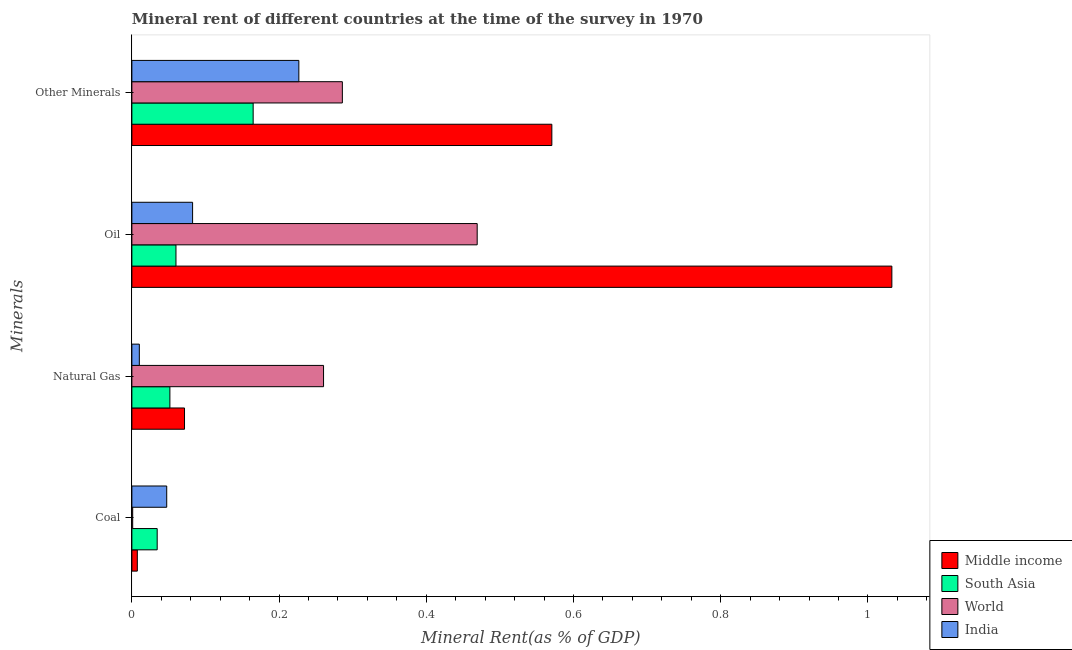How many groups of bars are there?
Provide a succinct answer. 4. Are the number of bars per tick equal to the number of legend labels?
Provide a short and direct response. Yes. Are the number of bars on each tick of the Y-axis equal?
Your answer should be compact. Yes. What is the label of the 3rd group of bars from the top?
Your response must be concise. Natural Gas. What is the  rent of other minerals in South Asia?
Provide a short and direct response. 0.16. Across all countries, what is the maximum natural gas rent?
Your response must be concise. 0.26. Across all countries, what is the minimum coal rent?
Make the answer very short. 0. What is the total coal rent in the graph?
Ensure brevity in your answer.  0.09. What is the difference between the natural gas rent in Middle income and that in South Asia?
Your answer should be very brief. 0.02. What is the difference between the  rent of other minerals in Middle income and the oil rent in World?
Give a very brief answer. 0.1. What is the average oil rent per country?
Offer a terse response. 0.41. What is the difference between the natural gas rent and coal rent in India?
Offer a terse response. -0.04. What is the ratio of the  rent of other minerals in South Asia to that in World?
Offer a very short reply. 0.58. Is the coal rent in Middle income less than that in India?
Keep it short and to the point. Yes. What is the difference between the highest and the second highest natural gas rent?
Your response must be concise. 0.19. What is the difference between the highest and the lowest coal rent?
Make the answer very short. 0.05. In how many countries, is the coal rent greater than the average coal rent taken over all countries?
Give a very brief answer. 2. Is the sum of the oil rent in World and South Asia greater than the maximum coal rent across all countries?
Offer a very short reply. Yes. What does the 4th bar from the bottom in Other Minerals represents?
Offer a terse response. India. Is it the case that in every country, the sum of the coal rent and natural gas rent is greater than the oil rent?
Your answer should be compact. No. Are all the bars in the graph horizontal?
Give a very brief answer. Yes. What is the difference between two consecutive major ticks on the X-axis?
Offer a terse response. 0.2. Does the graph contain any zero values?
Offer a terse response. No. Does the graph contain grids?
Provide a succinct answer. No. Where does the legend appear in the graph?
Provide a short and direct response. Bottom right. How many legend labels are there?
Give a very brief answer. 4. What is the title of the graph?
Make the answer very short. Mineral rent of different countries at the time of the survey in 1970. What is the label or title of the X-axis?
Ensure brevity in your answer.  Mineral Rent(as % of GDP). What is the label or title of the Y-axis?
Give a very brief answer. Minerals. What is the Mineral Rent(as % of GDP) of Middle income in Coal?
Give a very brief answer. 0.01. What is the Mineral Rent(as % of GDP) in South Asia in Coal?
Provide a short and direct response. 0.03. What is the Mineral Rent(as % of GDP) in World in Coal?
Offer a very short reply. 0. What is the Mineral Rent(as % of GDP) of India in Coal?
Your response must be concise. 0.05. What is the Mineral Rent(as % of GDP) in Middle income in Natural Gas?
Provide a short and direct response. 0.07. What is the Mineral Rent(as % of GDP) in South Asia in Natural Gas?
Give a very brief answer. 0.05. What is the Mineral Rent(as % of GDP) in World in Natural Gas?
Offer a terse response. 0.26. What is the Mineral Rent(as % of GDP) in India in Natural Gas?
Your response must be concise. 0.01. What is the Mineral Rent(as % of GDP) of Middle income in Oil?
Offer a terse response. 1.03. What is the Mineral Rent(as % of GDP) in South Asia in Oil?
Ensure brevity in your answer.  0.06. What is the Mineral Rent(as % of GDP) in World in Oil?
Your answer should be very brief. 0.47. What is the Mineral Rent(as % of GDP) in India in Oil?
Ensure brevity in your answer.  0.08. What is the Mineral Rent(as % of GDP) of Middle income in Other Minerals?
Make the answer very short. 0.57. What is the Mineral Rent(as % of GDP) of South Asia in Other Minerals?
Your response must be concise. 0.16. What is the Mineral Rent(as % of GDP) in World in Other Minerals?
Provide a succinct answer. 0.29. What is the Mineral Rent(as % of GDP) of India in Other Minerals?
Provide a short and direct response. 0.23. Across all Minerals, what is the maximum Mineral Rent(as % of GDP) in Middle income?
Provide a succinct answer. 1.03. Across all Minerals, what is the maximum Mineral Rent(as % of GDP) in South Asia?
Your answer should be compact. 0.16. Across all Minerals, what is the maximum Mineral Rent(as % of GDP) of World?
Provide a succinct answer. 0.47. Across all Minerals, what is the maximum Mineral Rent(as % of GDP) in India?
Give a very brief answer. 0.23. Across all Minerals, what is the minimum Mineral Rent(as % of GDP) of Middle income?
Your answer should be very brief. 0.01. Across all Minerals, what is the minimum Mineral Rent(as % of GDP) of South Asia?
Ensure brevity in your answer.  0.03. Across all Minerals, what is the minimum Mineral Rent(as % of GDP) in World?
Provide a succinct answer. 0. Across all Minerals, what is the minimum Mineral Rent(as % of GDP) of India?
Provide a succinct answer. 0.01. What is the total Mineral Rent(as % of GDP) in Middle income in the graph?
Your answer should be compact. 1.68. What is the total Mineral Rent(as % of GDP) of South Asia in the graph?
Keep it short and to the point. 0.31. What is the total Mineral Rent(as % of GDP) in World in the graph?
Offer a terse response. 1.02. What is the total Mineral Rent(as % of GDP) of India in the graph?
Your answer should be compact. 0.37. What is the difference between the Mineral Rent(as % of GDP) of Middle income in Coal and that in Natural Gas?
Make the answer very short. -0.06. What is the difference between the Mineral Rent(as % of GDP) in South Asia in Coal and that in Natural Gas?
Your answer should be compact. -0.02. What is the difference between the Mineral Rent(as % of GDP) of World in Coal and that in Natural Gas?
Provide a succinct answer. -0.26. What is the difference between the Mineral Rent(as % of GDP) of India in Coal and that in Natural Gas?
Your response must be concise. 0.04. What is the difference between the Mineral Rent(as % of GDP) in Middle income in Coal and that in Oil?
Give a very brief answer. -1.02. What is the difference between the Mineral Rent(as % of GDP) of South Asia in Coal and that in Oil?
Offer a very short reply. -0.03. What is the difference between the Mineral Rent(as % of GDP) in World in Coal and that in Oil?
Ensure brevity in your answer.  -0.47. What is the difference between the Mineral Rent(as % of GDP) in India in Coal and that in Oil?
Provide a short and direct response. -0.04. What is the difference between the Mineral Rent(as % of GDP) in Middle income in Coal and that in Other Minerals?
Provide a succinct answer. -0.56. What is the difference between the Mineral Rent(as % of GDP) of South Asia in Coal and that in Other Minerals?
Make the answer very short. -0.13. What is the difference between the Mineral Rent(as % of GDP) of World in Coal and that in Other Minerals?
Provide a succinct answer. -0.28. What is the difference between the Mineral Rent(as % of GDP) of India in Coal and that in Other Minerals?
Ensure brevity in your answer.  -0.18. What is the difference between the Mineral Rent(as % of GDP) in Middle income in Natural Gas and that in Oil?
Ensure brevity in your answer.  -0.96. What is the difference between the Mineral Rent(as % of GDP) in South Asia in Natural Gas and that in Oil?
Provide a succinct answer. -0.01. What is the difference between the Mineral Rent(as % of GDP) of World in Natural Gas and that in Oil?
Provide a short and direct response. -0.21. What is the difference between the Mineral Rent(as % of GDP) of India in Natural Gas and that in Oil?
Your answer should be compact. -0.07. What is the difference between the Mineral Rent(as % of GDP) of Middle income in Natural Gas and that in Other Minerals?
Give a very brief answer. -0.5. What is the difference between the Mineral Rent(as % of GDP) in South Asia in Natural Gas and that in Other Minerals?
Your response must be concise. -0.11. What is the difference between the Mineral Rent(as % of GDP) of World in Natural Gas and that in Other Minerals?
Offer a terse response. -0.03. What is the difference between the Mineral Rent(as % of GDP) of India in Natural Gas and that in Other Minerals?
Give a very brief answer. -0.22. What is the difference between the Mineral Rent(as % of GDP) in Middle income in Oil and that in Other Minerals?
Offer a terse response. 0.46. What is the difference between the Mineral Rent(as % of GDP) of South Asia in Oil and that in Other Minerals?
Offer a very short reply. -0.1. What is the difference between the Mineral Rent(as % of GDP) of World in Oil and that in Other Minerals?
Ensure brevity in your answer.  0.18. What is the difference between the Mineral Rent(as % of GDP) in India in Oil and that in Other Minerals?
Offer a terse response. -0.14. What is the difference between the Mineral Rent(as % of GDP) of Middle income in Coal and the Mineral Rent(as % of GDP) of South Asia in Natural Gas?
Provide a succinct answer. -0.04. What is the difference between the Mineral Rent(as % of GDP) in Middle income in Coal and the Mineral Rent(as % of GDP) in World in Natural Gas?
Your answer should be very brief. -0.25. What is the difference between the Mineral Rent(as % of GDP) of Middle income in Coal and the Mineral Rent(as % of GDP) of India in Natural Gas?
Offer a terse response. -0. What is the difference between the Mineral Rent(as % of GDP) of South Asia in Coal and the Mineral Rent(as % of GDP) of World in Natural Gas?
Offer a very short reply. -0.23. What is the difference between the Mineral Rent(as % of GDP) in South Asia in Coal and the Mineral Rent(as % of GDP) in India in Natural Gas?
Ensure brevity in your answer.  0.02. What is the difference between the Mineral Rent(as % of GDP) of World in Coal and the Mineral Rent(as % of GDP) of India in Natural Gas?
Keep it short and to the point. -0.01. What is the difference between the Mineral Rent(as % of GDP) in Middle income in Coal and the Mineral Rent(as % of GDP) in South Asia in Oil?
Ensure brevity in your answer.  -0.05. What is the difference between the Mineral Rent(as % of GDP) in Middle income in Coal and the Mineral Rent(as % of GDP) in World in Oil?
Your answer should be very brief. -0.46. What is the difference between the Mineral Rent(as % of GDP) in Middle income in Coal and the Mineral Rent(as % of GDP) in India in Oil?
Keep it short and to the point. -0.08. What is the difference between the Mineral Rent(as % of GDP) in South Asia in Coal and the Mineral Rent(as % of GDP) in World in Oil?
Provide a succinct answer. -0.43. What is the difference between the Mineral Rent(as % of GDP) of South Asia in Coal and the Mineral Rent(as % of GDP) of India in Oil?
Ensure brevity in your answer.  -0.05. What is the difference between the Mineral Rent(as % of GDP) in World in Coal and the Mineral Rent(as % of GDP) in India in Oil?
Your response must be concise. -0.08. What is the difference between the Mineral Rent(as % of GDP) in Middle income in Coal and the Mineral Rent(as % of GDP) in South Asia in Other Minerals?
Keep it short and to the point. -0.16. What is the difference between the Mineral Rent(as % of GDP) of Middle income in Coal and the Mineral Rent(as % of GDP) of World in Other Minerals?
Provide a succinct answer. -0.28. What is the difference between the Mineral Rent(as % of GDP) of Middle income in Coal and the Mineral Rent(as % of GDP) of India in Other Minerals?
Give a very brief answer. -0.22. What is the difference between the Mineral Rent(as % of GDP) of South Asia in Coal and the Mineral Rent(as % of GDP) of World in Other Minerals?
Offer a terse response. -0.25. What is the difference between the Mineral Rent(as % of GDP) in South Asia in Coal and the Mineral Rent(as % of GDP) in India in Other Minerals?
Your answer should be compact. -0.19. What is the difference between the Mineral Rent(as % of GDP) in World in Coal and the Mineral Rent(as % of GDP) in India in Other Minerals?
Make the answer very short. -0.23. What is the difference between the Mineral Rent(as % of GDP) of Middle income in Natural Gas and the Mineral Rent(as % of GDP) of South Asia in Oil?
Provide a short and direct response. 0.01. What is the difference between the Mineral Rent(as % of GDP) of Middle income in Natural Gas and the Mineral Rent(as % of GDP) of World in Oil?
Offer a terse response. -0.4. What is the difference between the Mineral Rent(as % of GDP) of Middle income in Natural Gas and the Mineral Rent(as % of GDP) of India in Oil?
Ensure brevity in your answer.  -0.01. What is the difference between the Mineral Rent(as % of GDP) in South Asia in Natural Gas and the Mineral Rent(as % of GDP) in World in Oil?
Provide a short and direct response. -0.42. What is the difference between the Mineral Rent(as % of GDP) in South Asia in Natural Gas and the Mineral Rent(as % of GDP) in India in Oil?
Give a very brief answer. -0.03. What is the difference between the Mineral Rent(as % of GDP) in World in Natural Gas and the Mineral Rent(as % of GDP) in India in Oil?
Make the answer very short. 0.18. What is the difference between the Mineral Rent(as % of GDP) in Middle income in Natural Gas and the Mineral Rent(as % of GDP) in South Asia in Other Minerals?
Offer a terse response. -0.09. What is the difference between the Mineral Rent(as % of GDP) in Middle income in Natural Gas and the Mineral Rent(as % of GDP) in World in Other Minerals?
Make the answer very short. -0.21. What is the difference between the Mineral Rent(as % of GDP) in Middle income in Natural Gas and the Mineral Rent(as % of GDP) in India in Other Minerals?
Your response must be concise. -0.16. What is the difference between the Mineral Rent(as % of GDP) in South Asia in Natural Gas and the Mineral Rent(as % of GDP) in World in Other Minerals?
Provide a succinct answer. -0.23. What is the difference between the Mineral Rent(as % of GDP) in South Asia in Natural Gas and the Mineral Rent(as % of GDP) in India in Other Minerals?
Give a very brief answer. -0.18. What is the difference between the Mineral Rent(as % of GDP) of World in Natural Gas and the Mineral Rent(as % of GDP) of India in Other Minerals?
Give a very brief answer. 0.03. What is the difference between the Mineral Rent(as % of GDP) in Middle income in Oil and the Mineral Rent(as % of GDP) in South Asia in Other Minerals?
Ensure brevity in your answer.  0.87. What is the difference between the Mineral Rent(as % of GDP) of Middle income in Oil and the Mineral Rent(as % of GDP) of World in Other Minerals?
Give a very brief answer. 0.75. What is the difference between the Mineral Rent(as % of GDP) in Middle income in Oil and the Mineral Rent(as % of GDP) in India in Other Minerals?
Ensure brevity in your answer.  0.81. What is the difference between the Mineral Rent(as % of GDP) of South Asia in Oil and the Mineral Rent(as % of GDP) of World in Other Minerals?
Make the answer very short. -0.23. What is the difference between the Mineral Rent(as % of GDP) in South Asia in Oil and the Mineral Rent(as % of GDP) in India in Other Minerals?
Offer a very short reply. -0.17. What is the difference between the Mineral Rent(as % of GDP) of World in Oil and the Mineral Rent(as % of GDP) of India in Other Minerals?
Offer a terse response. 0.24. What is the average Mineral Rent(as % of GDP) of Middle income per Minerals?
Your answer should be very brief. 0.42. What is the average Mineral Rent(as % of GDP) in South Asia per Minerals?
Your answer should be very brief. 0.08. What is the average Mineral Rent(as % of GDP) in World per Minerals?
Offer a terse response. 0.25. What is the average Mineral Rent(as % of GDP) in India per Minerals?
Offer a very short reply. 0.09. What is the difference between the Mineral Rent(as % of GDP) in Middle income and Mineral Rent(as % of GDP) in South Asia in Coal?
Give a very brief answer. -0.03. What is the difference between the Mineral Rent(as % of GDP) of Middle income and Mineral Rent(as % of GDP) of World in Coal?
Provide a succinct answer. 0.01. What is the difference between the Mineral Rent(as % of GDP) of Middle income and Mineral Rent(as % of GDP) of India in Coal?
Your answer should be very brief. -0.04. What is the difference between the Mineral Rent(as % of GDP) in South Asia and Mineral Rent(as % of GDP) in India in Coal?
Ensure brevity in your answer.  -0.01. What is the difference between the Mineral Rent(as % of GDP) in World and Mineral Rent(as % of GDP) in India in Coal?
Make the answer very short. -0.05. What is the difference between the Mineral Rent(as % of GDP) in Middle income and Mineral Rent(as % of GDP) in South Asia in Natural Gas?
Offer a terse response. 0.02. What is the difference between the Mineral Rent(as % of GDP) of Middle income and Mineral Rent(as % of GDP) of World in Natural Gas?
Offer a terse response. -0.19. What is the difference between the Mineral Rent(as % of GDP) in Middle income and Mineral Rent(as % of GDP) in India in Natural Gas?
Provide a short and direct response. 0.06. What is the difference between the Mineral Rent(as % of GDP) of South Asia and Mineral Rent(as % of GDP) of World in Natural Gas?
Your response must be concise. -0.21. What is the difference between the Mineral Rent(as % of GDP) of South Asia and Mineral Rent(as % of GDP) of India in Natural Gas?
Offer a very short reply. 0.04. What is the difference between the Mineral Rent(as % of GDP) in World and Mineral Rent(as % of GDP) in India in Natural Gas?
Your answer should be compact. 0.25. What is the difference between the Mineral Rent(as % of GDP) of Middle income and Mineral Rent(as % of GDP) of South Asia in Oil?
Keep it short and to the point. 0.97. What is the difference between the Mineral Rent(as % of GDP) of Middle income and Mineral Rent(as % of GDP) of World in Oil?
Your response must be concise. 0.56. What is the difference between the Mineral Rent(as % of GDP) of South Asia and Mineral Rent(as % of GDP) of World in Oil?
Your answer should be very brief. -0.41. What is the difference between the Mineral Rent(as % of GDP) in South Asia and Mineral Rent(as % of GDP) in India in Oil?
Your response must be concise. -0.02. What is the difference between the Mineral Rent(as % of GDP) of World and Mineral Rent(as % of GDP) of India in Oil?
Your answer should be very brief. 0.39. What is the difference between the Mineral Rent(as % of GDP) of Middle income and Mineral Rent(as % of GDP) of South Asia in Other Minerals?
Offer a terse response. 0.41. What is the difference between the Mineral Rent(as % of GDP) in Middle income and Mineral Rent(as % of GDP) in World in Other Minerals?
Ensure brevity in your answer.  0.28. What is the difference between the Mineral Rent(as % of GDP) in Middle income and Mineral Rent(as % of GDP) in India in Other Minerals?
Ensure brevity in your answer.  0.34. What is the difference between the Mineral Rent(as % of GDP) of South Asia and Mineral Rent(as % of GDP) of World in Other Minerals?
Your answer should be very brief. -0.12. What is the difference between the Mineral Rent(as % of GDP) in South Asia and Mineral Rent(as % of GDP) in India in Other Minerals?
Your response must be concise. -0.06. What is the difference between the Mineral Rent(as % of GDP) of World and Mineral Rent(as % of GDP) of India in Other Minerals?
Provide a succinct answer. 0.06. What is the ratio of the Mineral Rent(as % of GDP) of Middle income in Coal to that in Natural Gas?
Your answer should be compact. 0.1. What is the ratio of the Mineral Rent(as % of GDP) of South Asia in Coal to that in Natural Gas?
Provide a short and direct response. 0.67. What is the ratio of the Mineral Rent(as % of GDP) of World in Coal to that in Natural Gas?
Provide a short and direct response. 0. What is the ratio of the Mineral Rent(as % of GDP) of India in Coal to that in Natural Gas?
Provide a short and direct response. 4.68. What is the ratio of the Mineral Rent(as % of GDP) of Middle income in Coal to that in Oil?
Provide a succinct answer. 0.01. What is the ratio of the Mineral Rent(as % of GDP) of South Asia in Coal to that in Oil?
Offer a very short reply. 0.57. What is the ratio of the Mineral Rent(as % of GDP) of World in Coal to that in Oil?
Keep it short and to the point. 0. What is the ratio of the Mineral Rent(as % of GDP) of India in Coal to that in Oil?
Your answer should be compact. 0.57. What is the ratio of the Mineral Rent(as % of GDP) of Middle income in Coal to that in Other Minerals?
Your answer should be compact. 0.01. What is the ratio of the Mineral Rent(as % of GDP) in South Asia in Coal to that in Other Minerals?
Offer a terse response. 0.21. What is the ratio of the Mineral Rent(as % of GDP) in World in Coal to that in Other Minerals?
Ensure brevity in your answer.  0. What is the ratio of the Mineral Rent(as % of GDP) in India in Coal to that in Other Minerals?
Provide a short and direct response. 0.21. What is the ratio of the Mineral Rent(as % of GDP) of Middle income in Natural Gas to that in Oil?
Provide a short and direct response. 0.07. What is the ratio of the Mineral Rent(as % of GDP) in South Asia in Natural Gas to that in Oil?
Your answer should be compact. 0.86. What is the ratio of the Mineral Rent(as % of GDP) in World in Natural Gas to that in Oil?
Make the answer very short. 0.56. What is the ratio of the Mineral Rent(as % of GDP) in India in Natural Gas to that in Oil?
Provide a succinct answer. 0.12. What is the ratio of the Mineral Rent(as % of GDP) in Middle income in Natural Gas to that in Other Minerals?
Keep it short and to the point. 0.13. What is the ratio of the Mineral Rent(as % of GDP) of South Asia in Natural Gas to that in Other Minerals?
Provide a short and direct response. 0.31. What is the ratio of the Mineral Rent(as % of GDP) of World in Natural Gas to that in Other Minerals?
Your response must be concise. 0.91. What is the ratio of the Mineral Rent(as % of GDP) in India in Natural Gas to that in Other Minerals?
Your response must be concise. 0.04. What is the ratio of the Mineral Rent(as % of GDP) in Middle income in Oil to that in Other Minerals?
Make the answer very short. 1.81. What is the ratio of the Mineral Rent(as % of GDP) in South Asia in Oil to that in Other Minerals?
Provide a short and direct response. 0.36. What is the ratio of the Mineral Rent(as % of GDP) of World in Oil to that in Other Minerals?
Provide a short and direct response. 1.64. What is the ratio of the Mineral Rent(as % of GDP) of India in Oil to that in Other Minerals?
Ensure brevity in your answer.  0.36. What is the difference between the highest and the second highest Mineral Rent(as % of GDP) in Middle income?
Make the answer very short. 0.46. What is the difference between the highest and the second highest Mineral Rent(as % of GDP) in South Asia?
Provide a succinct answer. 0.1. What is the difference between the highest and the second highest Mineral Rent(as % of GDP) of World?
Your answer should be very brief. 0.18. What is the difference between the highest and the second highest Mineral Rent(as % of GDP) in India?
Provide a succinct answer. 0.14. What is the difference between the highest and the lowest Mineral Rent(as % of GDP) in Middle income?
Your response must be concise. 1.02. What is the difference between the highest and the lowest Mineral Rent(as % of GDP) in South Asia?
Provide a short and direct response. 0.13. What is the difference between the highest and the lowest Mineral Rent(as % of GDP) of World?
Provide a short and direct response. 0.47. What is the difference between the highest and the lowest Mineral Rent(as % of GDP) of India?
Provide a succinct answer. 0.22. 